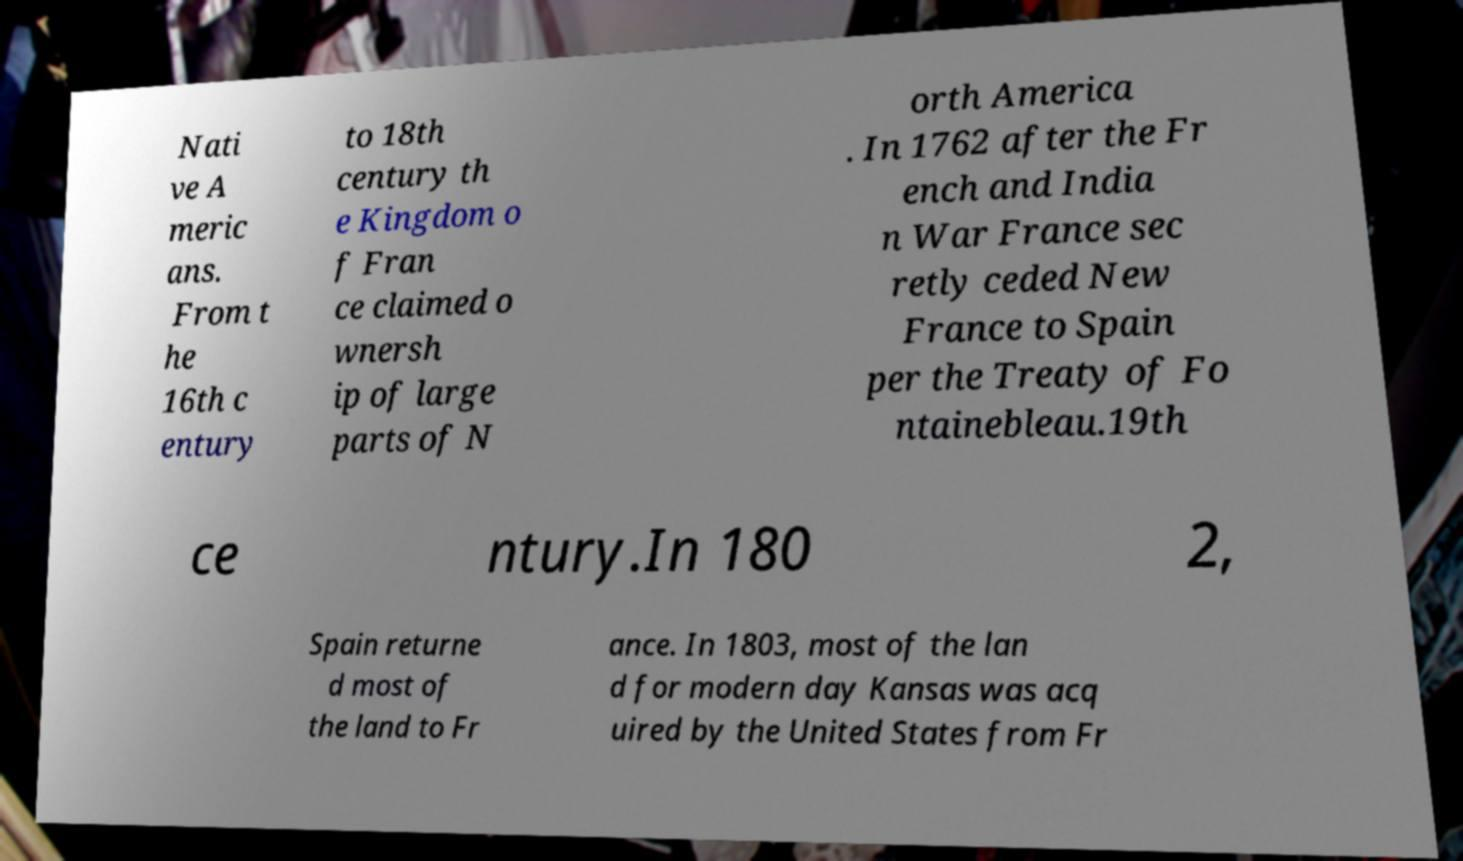For documentation purposes, I need the text within this image transcribed. Could you provide that? Nati ve A meric ans. From t he 16th c entury to 18th century th e Kingdom o f Fran ce claimed o wnersh ip of large parts of N orth America . In 1762 after the Fr ench and India n War France sec retly ceded New France to Spain per the Treaty of Fo ntainebleau.19th ce ntury.In 180 2, Spain returne d most of the land to Fr ance. In 1803, most of the lan d for modern day Kansas was acq uired by the United States from Fr 